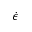<formula> <loc_0><loc_0><loc_500><loc_500>\dot { \epsilon }</formula> 